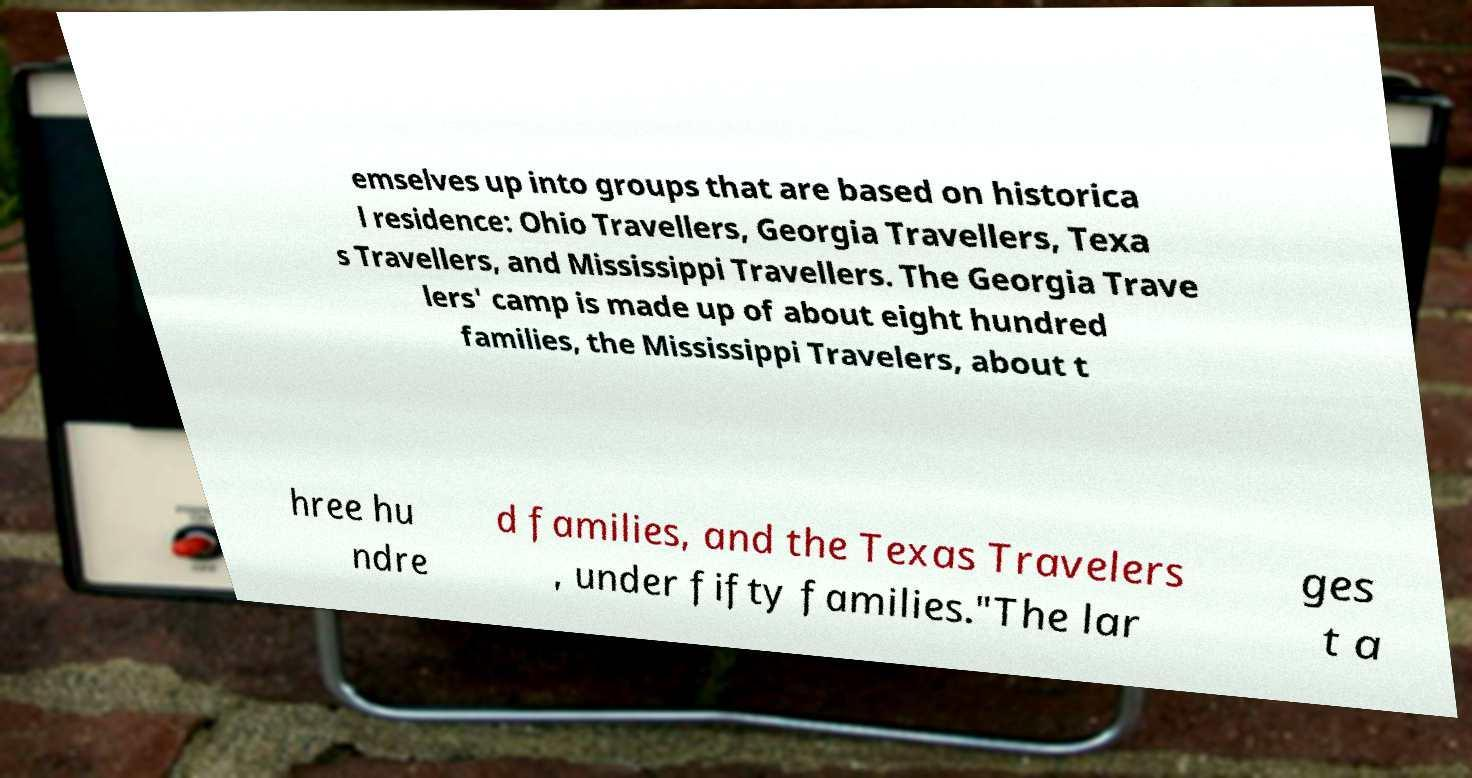Please read and relay the text visible in this image. What does it say? emselves up into groups that are based on historica l residence: Ohio Travellers, Georgia Travellers, Texa s Travellers, and Mississippi Travellers. The Georgia Trave lers' camp is made up of about eight hundred families, the Mississippi Travelers, about t hree hu ndre d families, and the Texas Travelers , under fifty families."The lar ges t a 